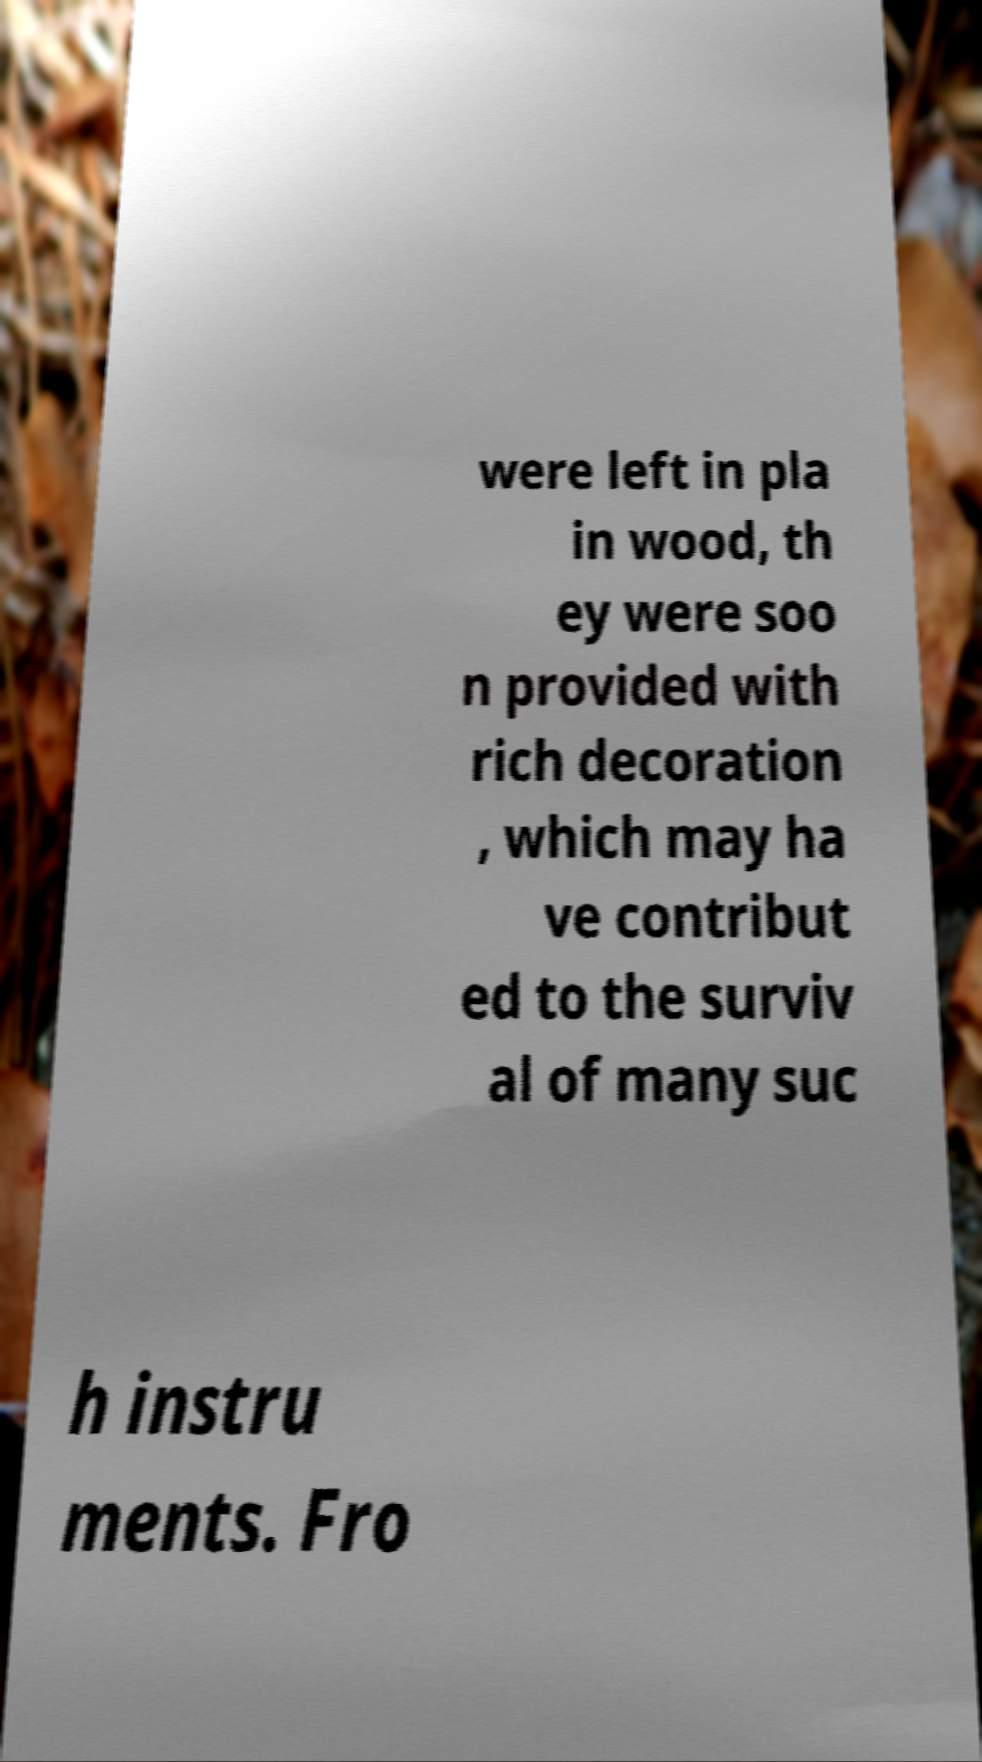I need the written content from this picture converted into text. Can you do that? were left in pla in wood, th ey were soo n provided with rich decoration , which may ha ve contribut ed to the surviv al of many suc h instru ments. Fro 